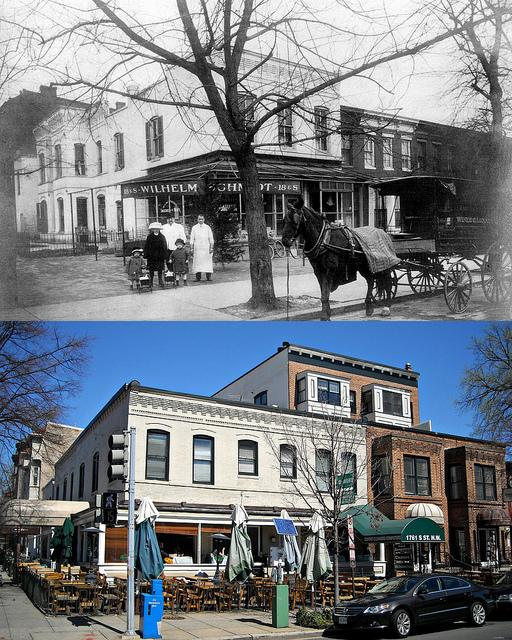Who do the umbrellas belong to?

Choices:
A) residents
B) store
C) city
D) restaurant restaurant 